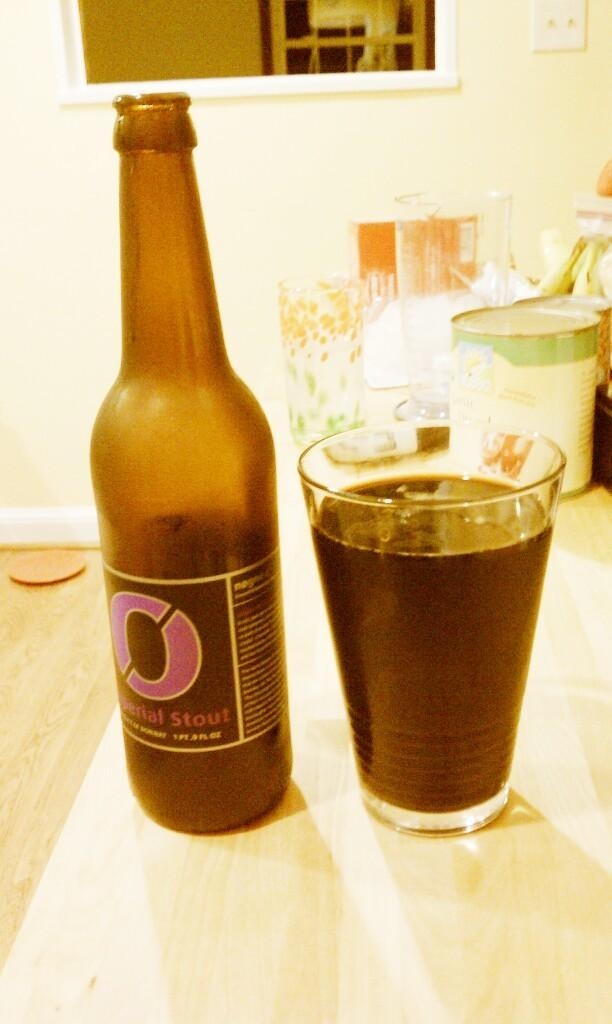<image>
Render a clear and concise summary of the photo. Bottle of serial stout and a glass of serial stout drink. 